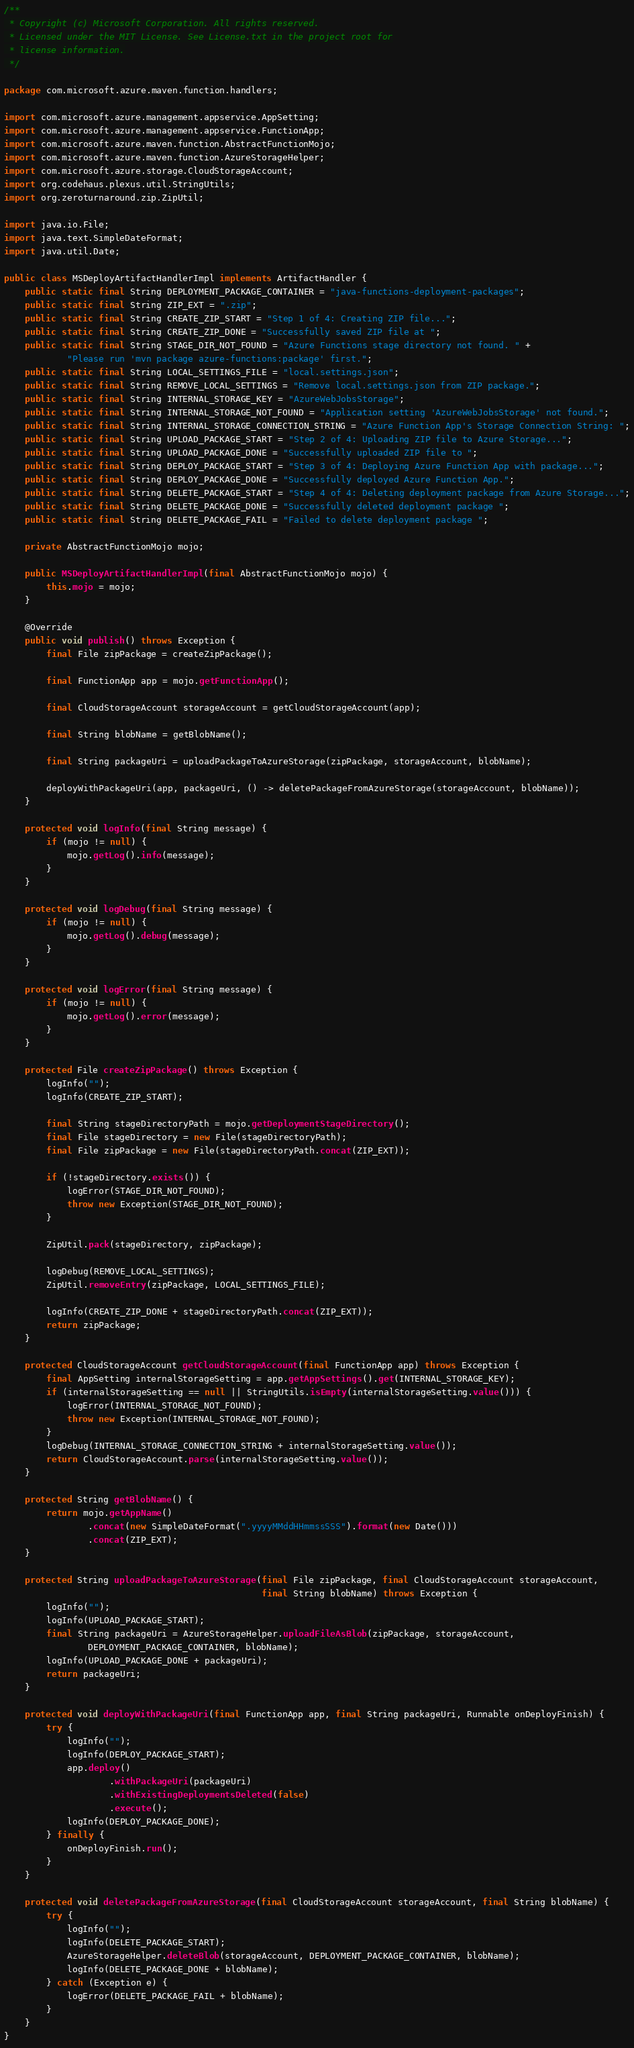<code> <loc_0><loc_0><loc_500><loc_500><_Java_>/**
 * Copyright (c) Microsoft Corporation. All rights reserved.
 * Licensed under the MIT License. See License.txt in the project root for
 * license information.
 */

package com.microsoft.azure.maven.function.handlers;

import com.microsoft.azure.management.appservice.AppSetting;
import com.microsoft.azure.management.appservice.FunctionApp;
import com.microsoft.azure.maven.function.AbstractFunctionMojo;
import com.microsoft.azure.maven.function.AzureStorageHelper;
import com.microsoft.azure.storage.CloudStorageAccount;
import org.codehaus.plexus.util.StringUtils;
import org.zeroturnaround.zip.ZipUtil;

import java.io.File;
import java.text.SimpleDateFormat;
import java.util.Date;

public class MSDeployArtifactHandlerImpl implements ArtifactHandler {
    public static final String DEPLOYMENT_PACKAGE_CONTAINER = "java-functions-deployment-packages";
    public static final String ZIP_EXT = ".zip";
    public static final String CREATE_ZIP_START = "Step 1 of 4: Creating ZIP file...";
    public static final String CREATE_ZIP_DONE = "Successfully saved ZIP file at ";
    public static final String STAGE_DIR_NOT_FOUND = "Azure Functions stage directory not found. " +
            "Please run 'mvn package azure-functions:package' first.";
    public static final String LOCAL_SETTINGS_FILE = "local.settings.json";
    public static final String REMOVE_LOCAL_SETTINGS = "Remove local.settings.json from ZIP package.";
    public static final String INTERNAL_STORAGE_KEY = "AzureWebJobsStorage";
    public static final String INTERNAL_STORAGE_NOT_FOUND = "Application setting 'AzureWebJobsStorage' not found.";
    public static final String INTERNAL_STORAGE_CONNECTION_STRING = "Azure Function App's Storage Connection String: ";
    public static final String UPLOAD_PACKAGE_START = "Step 2 of 4: Uploading ZIP file to Azure Storage...";
    public static final String UPLOAD_PACKAGE_DONE = "Successfully uploaded ZIP file to ";
    public static final String DEPLOY_PACKAGE_START = "Step 3 of 4: Deploying Azure Function App with package...";
    public static final String DEPLOY_PACKAGE_DONE = "Successfully deployed Azure Function App.";
    public static final String DELETE_PACKAGE_START = "Step 4 of 4: Deleting deployment package from Azure Storage...";
    public static final String DELETE_PACKAGE_DONE = "Successfully deleted deployment package ";
    public static final String DELETE_PACKAGE_FAIL = "Failed to delete deployment package ";

    private AbstractFunctionMojo mojo;

    public MSDeployArtifactHandlerImpl(final AbstractFunctionMojo mojo) {
        this.mojo = mojo;
    }

    @Override
    public void publish() throws Exception {
        final File zipPackage = createZipPackage();

        final FunctionApp app = mojo.getFunctionApp();

        final CloudStorageAccount storageAccount = getCloudStorageAccount(app);

        final String blobName = getBlobName();

        final String packageUri = uploadPackageToAzureStorage(zipPackage, storageAccount, blobName);

        deployWithPackageUri(app, packageUri, () -> deletePackageFromAzureStorage(storageAccount, blobName));
    }

    protected void logInfo(final String message) {
        if (mojo != null) {
            mojo.getLog().info(message);
        }
    }

    protected void logDebug(final String message) {
        if (mojo != null) {
            mojo.getLog().debug(message);
        }
    }

    protected void logError(final String message) {
        if (mojo != null) {
            mojo.getLog().error(message);
        }
    }

    protected File createZipPackage() throws Exception {
        logInfo("");
        logInfo(CREATE_ZIP_START);

        final String stageDirectoryPath = mojo.getDeploymentStageDirectory();
        final File stageDirectory = new File(stageDirectoryPath);
        final File zipPackage = new File(stageDirectoryPath.concat(ZIP_EXT));

        if (!stageDirectory.exists()) {
            logError(STAGE_DIR_NOT_FOUND);
            throw new Exception(STAGE_DIR_NOT_FOUND);
        }

        ZipUtil.pack(stageDirectory, zipPackage);

        logDebug(REMOVE_LOCAL_SETTINGS);
        ZipUtil.removeEntry(zipPackage, LOCAL_SETTINGS_FILE);

        logInfo(CREATE_ZIP_DONE + stageDirectoryPath.concat(ZIP_EXT));
        return zipPackage;
    }

    protected CloudStorageAccount getCloudStorageAccount(final FunctionApp app) throws Exception {
        final AppSetting internalStorageSetting = app.getAppSettings().get(INTERNAL_STORAGE_KEY);
        if (internalStorageSetting == null || StringUtils.isEmpty(internalStorageSetting.value())) {
            logError(INTERNAL_STORAGE_NOT_FOUND);
            throw new Exception(INTERNAL_STORAGE_NOT_FOUND);
        }
        logDebug(INTERNAL_STORAGE_CONNECTION_STRING + internalStorageSetting.value());
        return CloudStorageAccount.parse(internalStorageSetting.value());
    }

    protected String getBlobName() {
        return mojo.getAppName()
                .concat(new SimpleDateFormat(".yyyyMMddHHmmssSSS").format(new Date()))
                .concat(ZIP_EXT);
    }

    protected String uploadPackageToAzureStorage(final File zipPackage, final CloudStorageAccount storageAccount,
                                                 final String blobName) throws Exception {
        logInfo("");
        logInfo(UPLOAD_PACKAGE_START);
        final String packageUri = AzureStorageHelper.uploadFileAsBlob(zipPackage, storageAccount,
                DEPLOYMENT_PACKAGE_CONTAINER, blobName);
        logInfo(UPLOAD_PACKAGE_DONE + packageUri);
        return packageUri;
    }

    protected void deployWithPackageUri(final FunctionApp app, final String packageUri, Runnable onDeployFinish) {
        try {
            logInfo("");
            logInfo(DEPLOY_PACKAGE_START);
            app.deploy()
                    .withPackageUri(packageUri)
                    .withExistingDeploymentsDeleted(false)
                    .execute();
            logInfo(DEPLOY_PACKAGE_DONE);
        } finally {
            onDeployFinish.run();
        }
    }

    protected void deletePackageFromAzureStorage(final CloudStorageAccount storageAccount, final String blobName) {
        try {
            logInfo("");
            logInfo(DELETE_PACKAGE_START);
            AzureStorageHelper.deleteBlob(storageAccount, DEPLOYMENT_PACKAGE_CONTAINER, blobName);
            logInfo(DELETE_PACKAGE_DONE + blobName);
        } catch (Exception e) {
            logError(DELETE_PACKAGE_FAIL + blobName);
        }
    }
}
</code> 